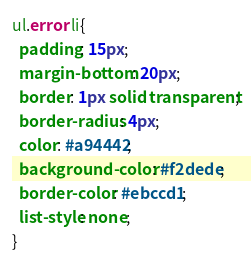<code> <loc_0><loc_0><loc_500><loc_500><_CSS_>ul.error li{
  padding: 15px;
  margin-bottom: 20px;
  border: 1px solid transparent;
  border-radius: 4px;
  color: #a94442;
  background-color: #f2dede;
  border-color: #ebccd1;
  list-style: none;
}</code> 